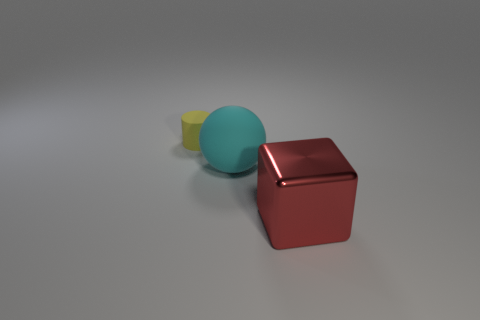Add 1 small red metallic cylinders. How many objects exist? 4 Subtract all cubes. How many objects are left? 2 Add 2 tiny rubber things. How many tiny rubber things are left? 3 Add 2 big cyan metal cylinders. How many big cyan metal cylinders exist? 2 Subtract 0 blue blocks. How many objects are left? 3 Subtract all matte spheres. Subtract all yellow matte cylinders. How many objects are left? 1 